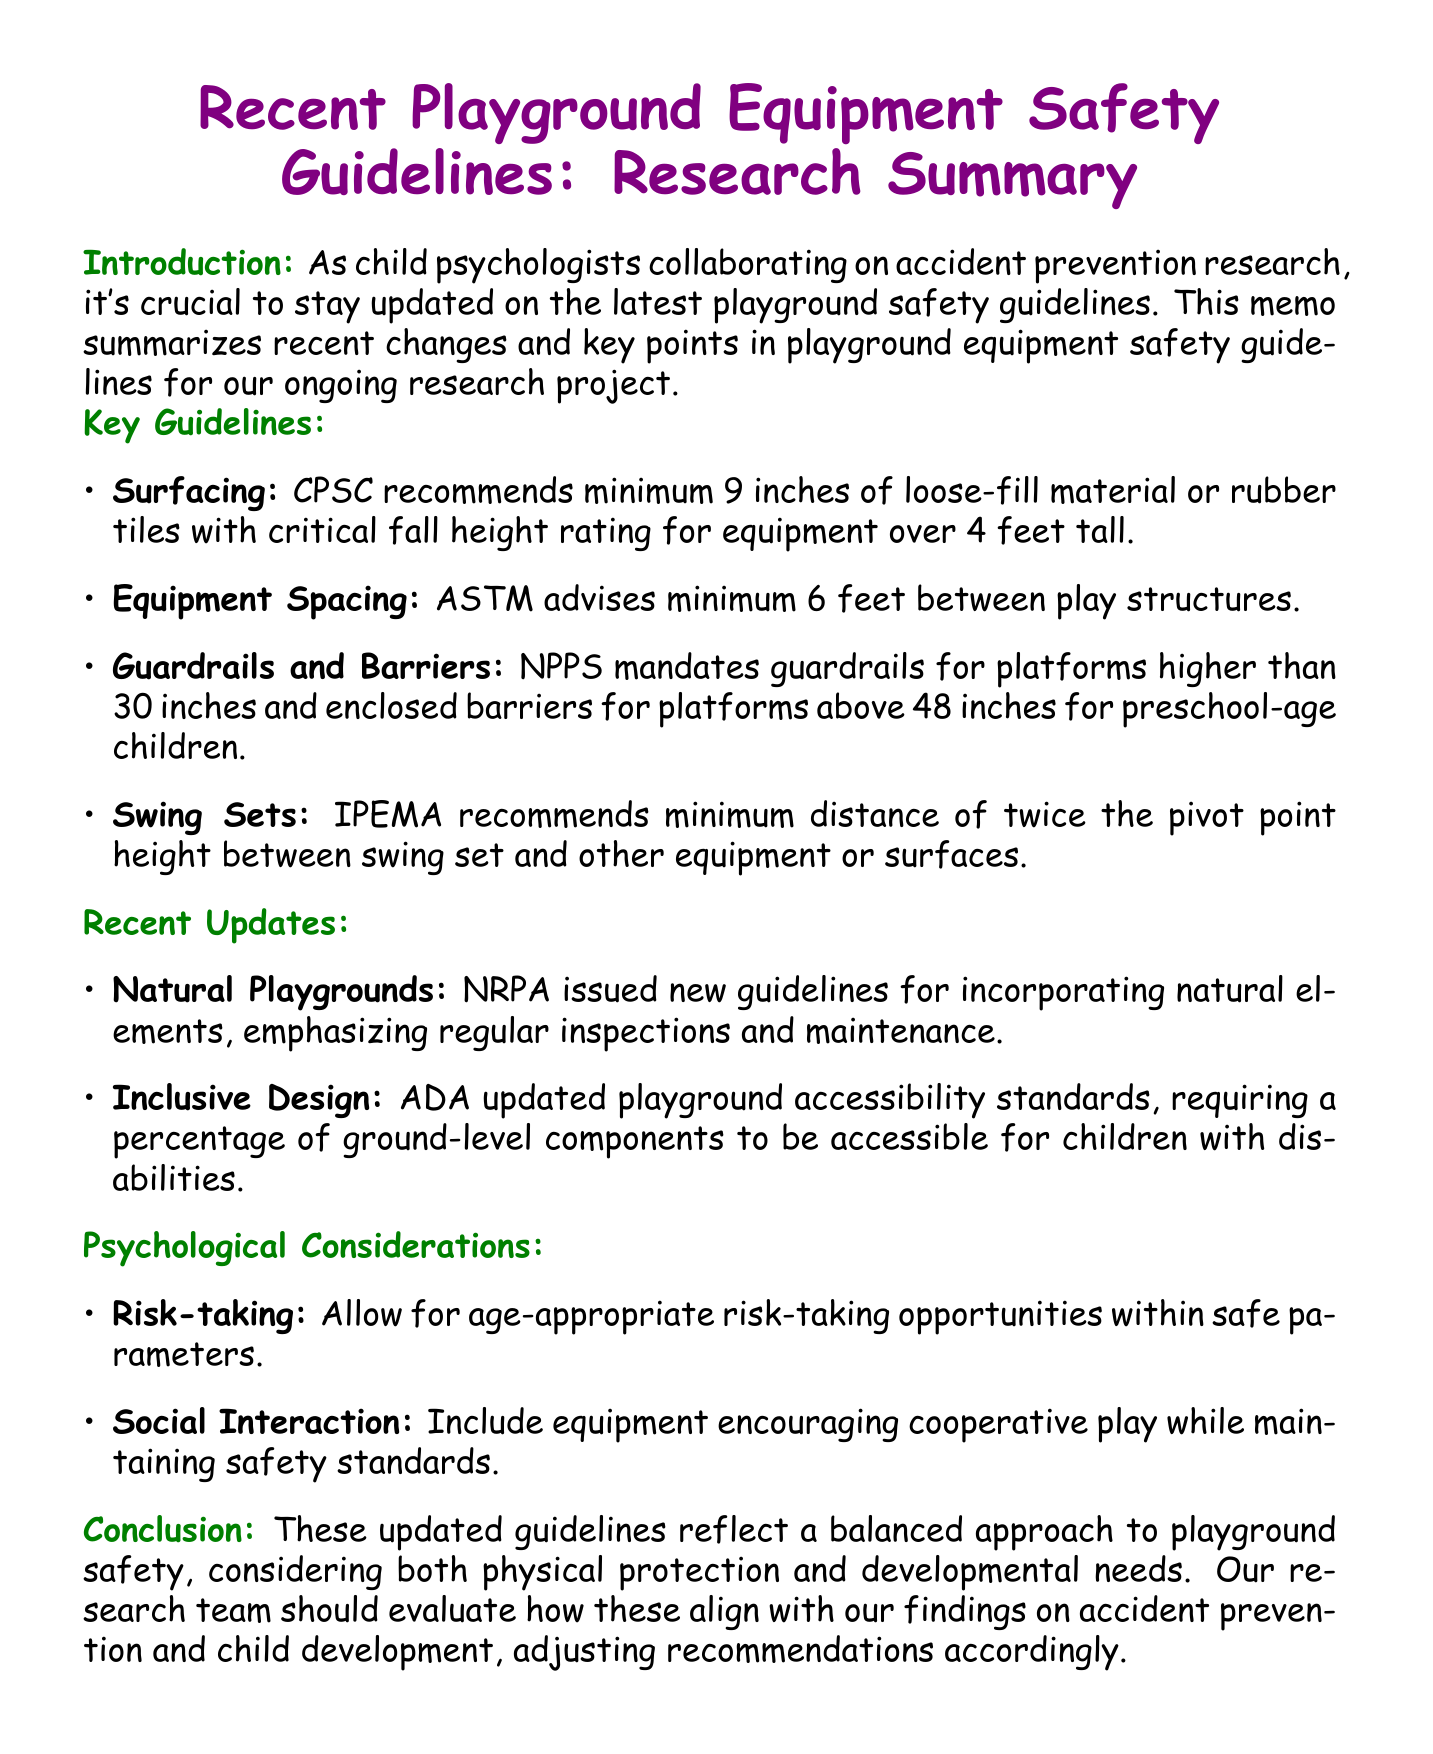what is the minimum depth of loose-fill material recommended for equipment over 4 feet tall? The CPSC recommends a minimum of 9 inches of loose-fill material or rubber tiles.
Answer: 9 inches what is the required spacing between play structures according to ASTM? The ASTM advises a minimum of 6 feet between play structures to prevent collisions.
Answer: 6 feet who mandates guardrails for platforms higher than 30 inches? The NPPS mandates guardrails for platforms higher than 30 inches.
Answer: NPPS which organization updated playground accessibility standards? The ADA updated the playground accessibility standards.
Answer: ADA what is the primary focus of the new guidelines for natural playgrounds issued by NRPA? The guidelines emphasize the importance of regular inspections and maintenance.
Answer: regular inspections and maintenance what should be included in playground design to support social development? Equipment that encourages cooperative play should be included.
Answer: cooperative play how does the document suggest balancing safety and development? It suggests incorporating challenging elements within safe parameters.
Answer: challenging elements within safe parameters what is the primary conclusion of the memo regarding playground safety? The memo states that the updated guidelines reflect a balanced approach to playground safety.
Answer: balanced approach to playground safety 